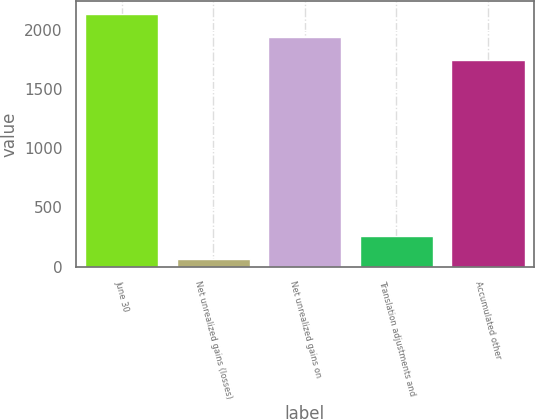Convert chart. <chart><loc_0><loc_0><loc_500><loc_500><bar_chart><fcel>June 30<fcel>Net unrealized gains (losses)<fcel>Net unrealized gains on<fcel>Translation adjustments and<fcel>Accumulated other<nl><fcel>2132.4<fcel>66<fcel>1937.7<fcel>260.7<fcel>1743<nl></chart> 